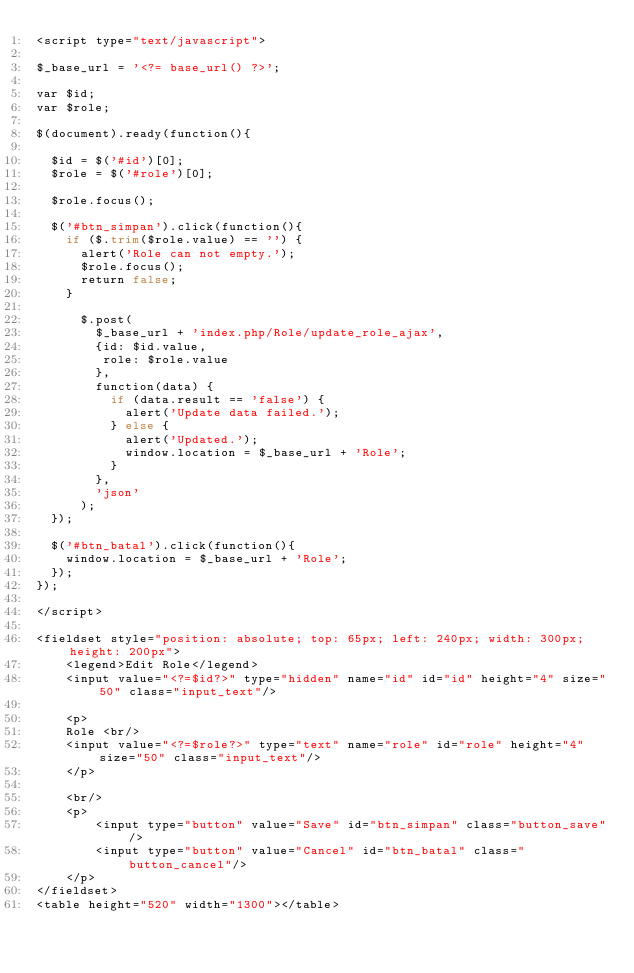<code> <loc_0><loc_0><loc_500><loc_500><_PHP_><script type="text/javascript">

$_base_url = '<?= base_url() ?>';

var $id;
var $role;

$(document).ready(function(){

  $id = $('#id')[0];
  $role = $('#role')[0];

  $role.focus();

  $('#btn_simpan').click(function(){
    if ($.trim($role.value) == '') {
      alert('Role can not empty.');
      $role.focus();
      return false;
    }
    
      $.post(
        $_base_url + 'index.php/Role/update_role_ajax',
        {id: $id.value,
         role: $role.value
        },
        function(data) {
          if (data.result == 'false') {
            alert('Update data failed.');
          } else {
            alert('Updated.');
            window.location = $_base_url + 'Role';
          }
        },
        'json'
      );
  });

  $('#btn_batal').click(function(){
    window.location = $_base_url + 'Role';
  });
});

</script>

<fieldset style="position: absolute; top: 65px; left: 240px; width: 300px; height: 200px">
    <legend>Edit Role</legend>
    <input value="<?=$id?>" type="hidden" name="id" id="id" height="4" size="50" class="input_text"/>
    
    <p>
    Role <br/>
    <input value="<?=$role?>" type="text" name="role" id="role" height="4" size="50" class="input_text"/>
    </p>
    
    <br/>
    <p>
        <input type="button" value="Save" id="btn_simpan" class="button_save"/>
        <input type="button" value="Cancel" id="btn_batal" class="button_cancel"/>
    </p>
</fieldset>
<table height="520" width="1300"></table></code> 